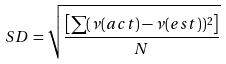Convert formula to latex. <formula><loc_0><loc_0><loc_500><loc_500>S D = \sqrt { \frac { \left [ \sum ( \nu ( a c t ) - \nu ( e s t ) ) ^ { 2 } \right ] } { N } }</formula> 